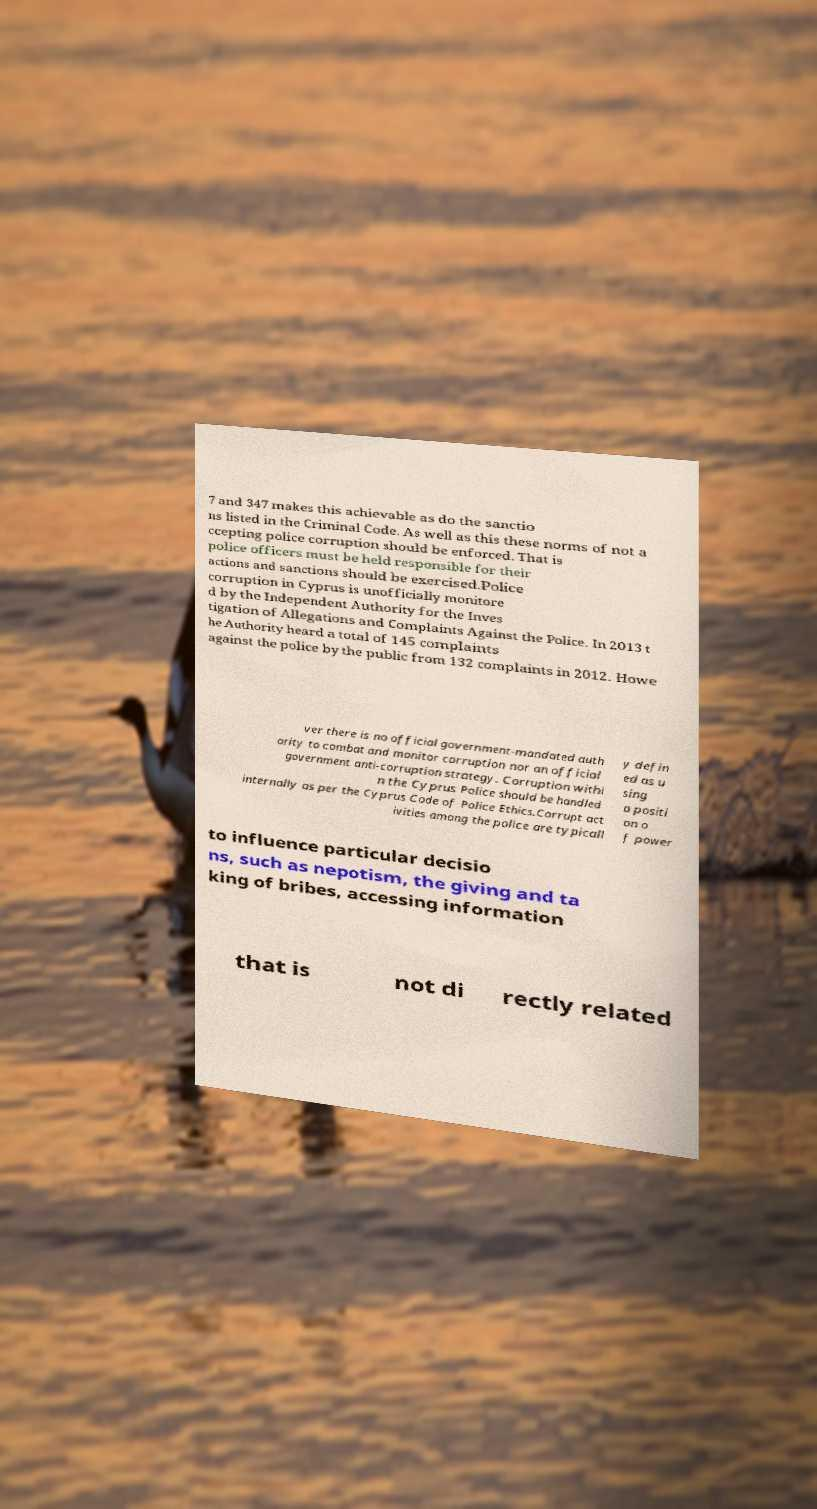Please identify and transcribe the text found in this image. 7 and 347 makes this achievable as do the sanctio ns listed in the Criminal Code. As well as this these norms of not a ccepting police corruption should be enforced. That is police officers must be held responsible for their actions and sanctions should be exercised.Police corruption in Cyprus is unofficially monitore d by the Independent Authority for the Inves tigation of Allegations and Complaints Against the Police. In 2013 t he Authority heard a total of 145 complaints against the police by the public from 132 complaints in 2012. Howe ver there is no official government-mandated auth ority to combat and monitor corruption nor an official government anti-corruption strategy. Corruption withi n the Cyprus Police should be handled internally as per the Cyprus Code of Police Ethics.Corrupt act ivities among the police are typicall y defin ed as u sing a positi on o f power to influence particular decisio ns, such as nepotism, the giving and ta king of bribes, accessing information that is not di rectly related 